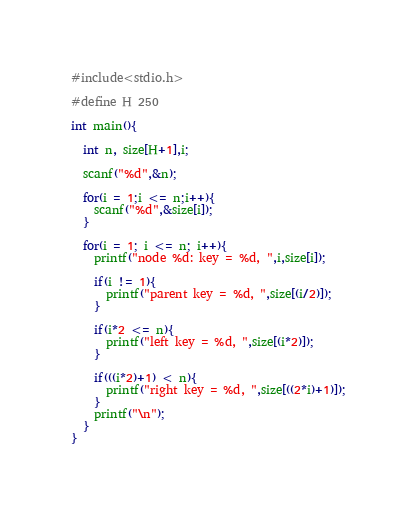<code> <loc_0><loc_0><loc_500><loc_500><_C_>#include<stdio.h>

#define H 250

int main(){

  int n, size[H+1],i;

  scanf("%d",&n);

  for(i = 1;i <= n;i++){
    scanf("%d",&size[i]);
  }

  for(i = 1; i <= n; i++){
    printf("node %d: key = %d, ",i,size[i]);
    
    if(i != 1){
      printf("parent key = %d, ",size[(i/2)]);
    }

    if(i*2 <= n){
      printf("left key = %d, ",size[(i*2)]);
    }

    if(((i*2)+1) < n){
      printf("right key = %d, ",size[((2*i)+1)]);
    }
    printf("\n");
  }
}</code> 